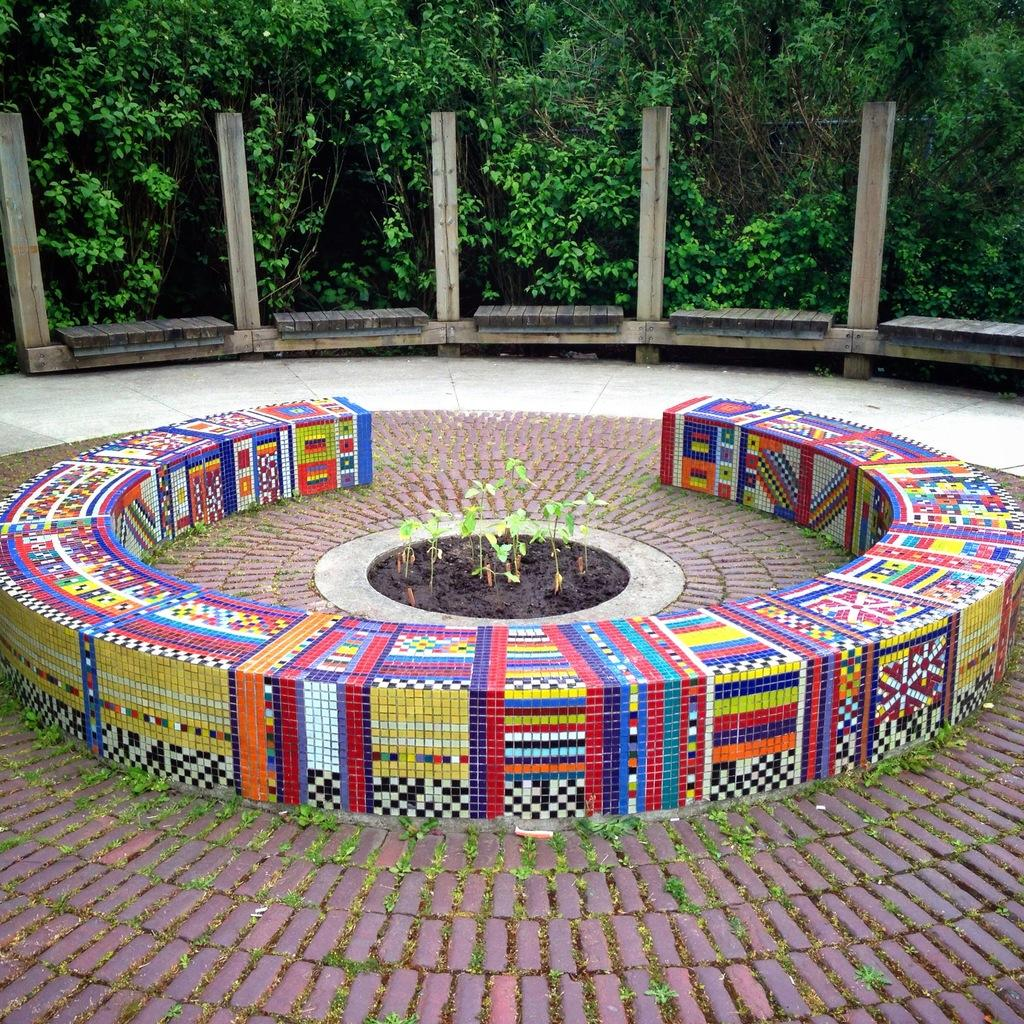What type of surface is visible in the image? There is a pavement in the image. What is placed on the pavement? There are plants on the pavement. What can be seen in the background of the image? There are poles and trees in the background of the image. What type of fowl is sitting on the tray in the image? There is no fowl or tray present in the image. What team is responsible for maintaining the plants on the pavement? The image does not provide information about a team responsible for maintaining the plants. 